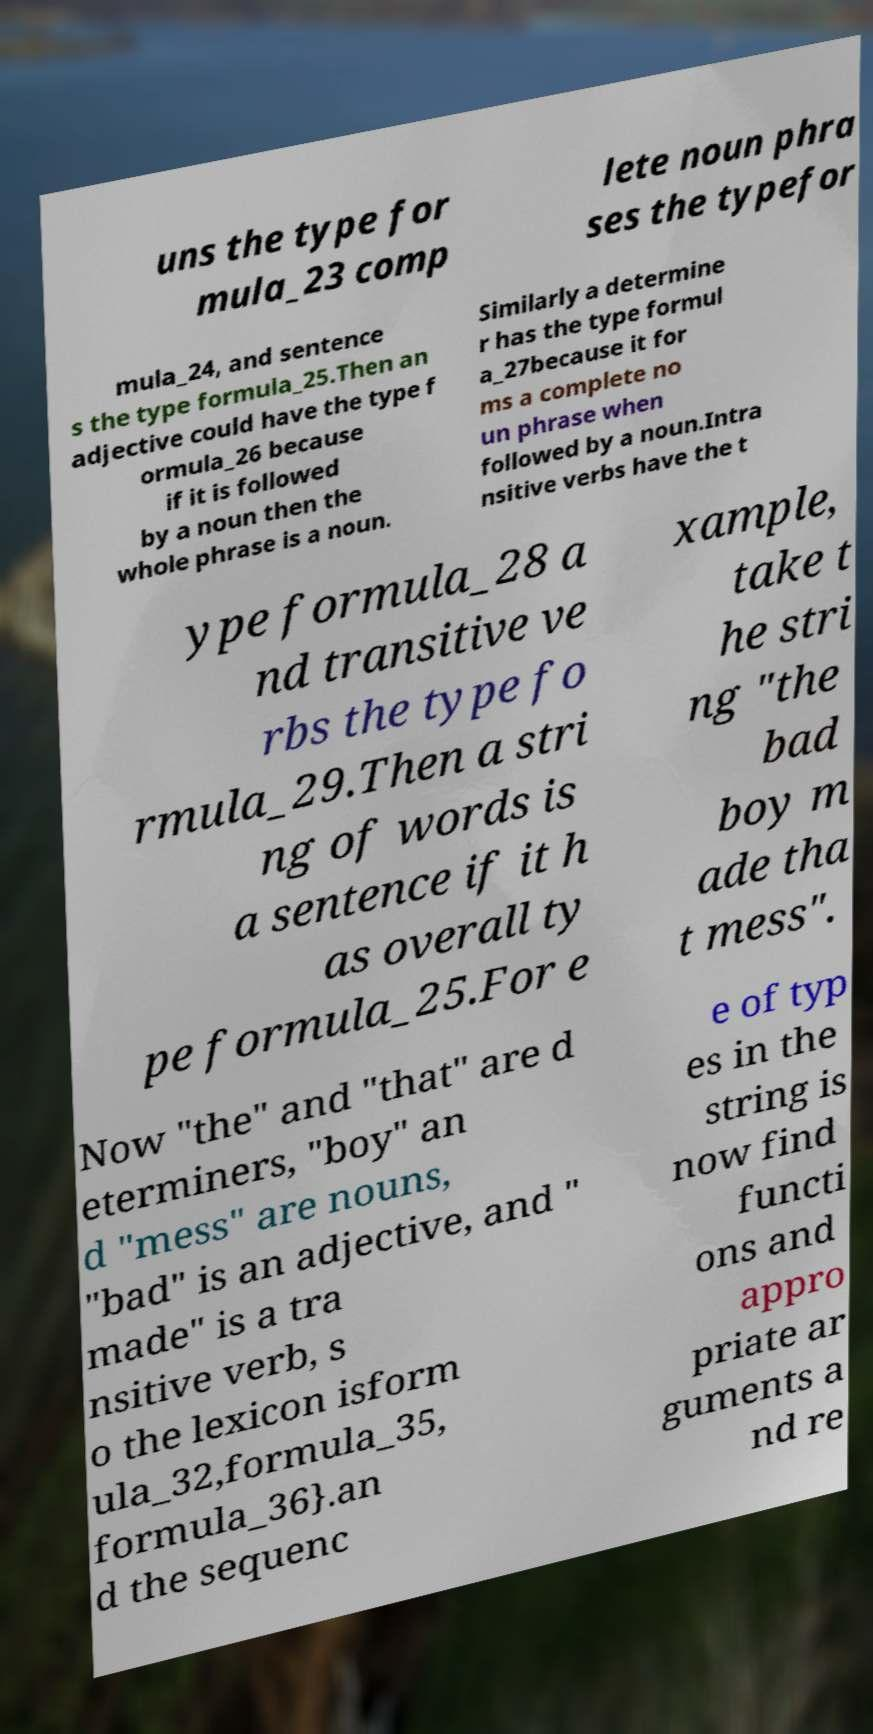What messages or text are displayed in this image? I need them in a readable, typed format. uns the type for mula_23 comp lete noun phra ses the typefor mula_24, and sentence s the type formula_25.Then an adjective could have the type f ormula_26 because if it is followed by a noun then the whole phrase is a noun. Similarly a determine r has the type formul a_27because it for ms a complete no un phrase when followed by a noun.Intra nsitive verbs have the t ype formula_28 a nd transitive ve rbs the type fo rmula_29.Then a stri ng of words is a sentence if it h as overall ty pe formula_25.For e xample, take t he stri ng "the bad boy m ade tha t mess". Now "the" and "that" are d eterminers, "boy" an d "mess" are nouns, "bad" is an adjective, and " made" is a tra nsitive verb, s o the lexicon isform ula_32,formula_35, formula_36}.an d the sequenc e of typ es in the string is now find functi ons and appro priate ar guments a nd re 